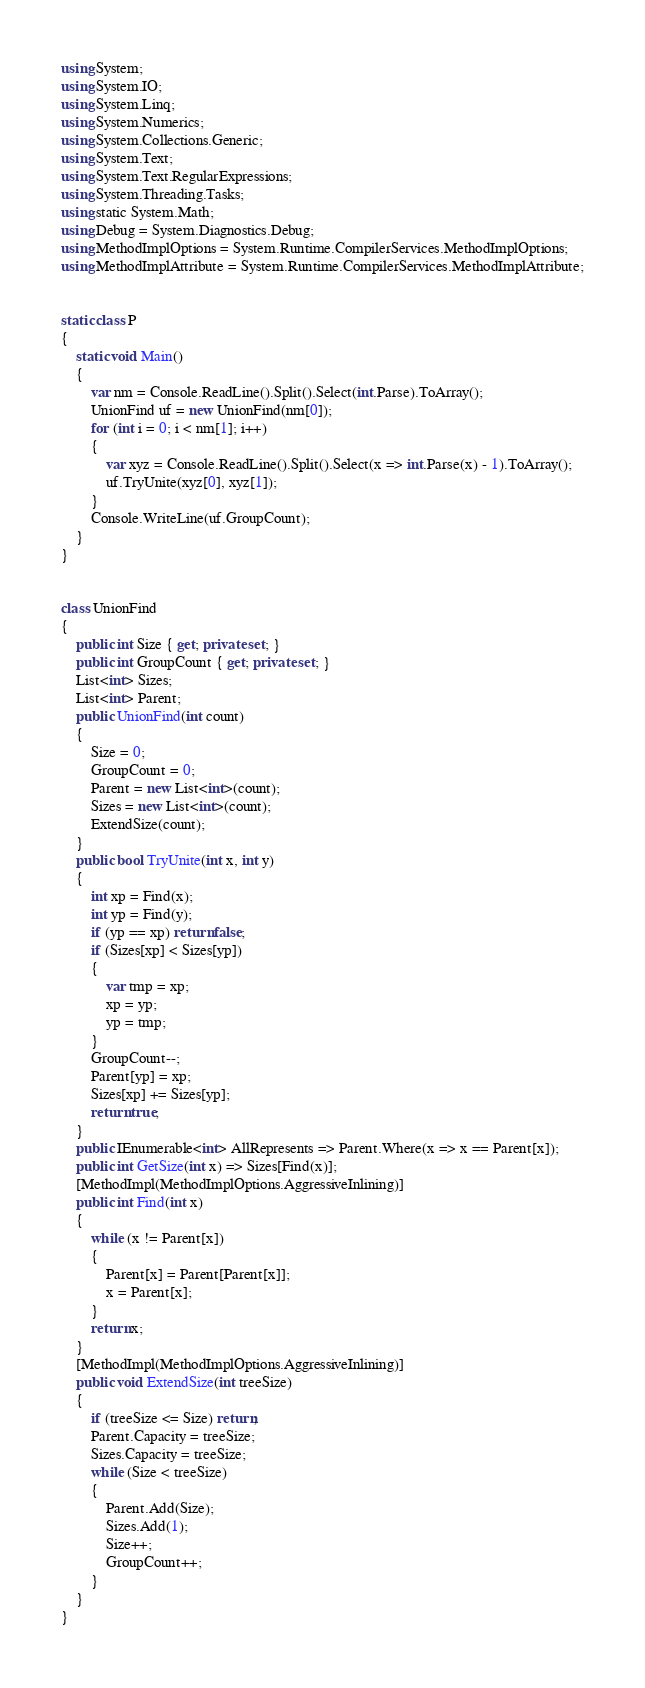Convert code to text. <code><loc_0><loc_0><loc_500><loc_500><_C#_>using System;
using System.IO;
using System.Linq;
using System.Numerics;
using System.Collections.Generic;
using System.Text;
using System.Text.RegularExpressions;
using System.Threading.Tasks;
using static System.Math;
using Debug = System.Diagnostics.Debug;
using MethodImplOptions = System.Runtime.CompilerServices.MethodImplOptions;
using MethodImplAttribute = System.Runtime.CompilerServices.MethodImplAttribute;


static class P
{
    static void Main()
    {
        var nm = Console.ReadLine().Split().Select(int.Parse).ToArray();
        UnionFind uf = new UnionFind(nm[0]);
        for (int i = 0; i < nm[1]; i++)
        {
            var xyz = Console.ReadLine().Split().Select(x => int.Parse(x) - 1).ToArray();
            uf.TryUnite(xyz[0], xyz[1]);
        }
        Console.WriteLine(uf.GroupCount);
    }
}


class UnionFind
{
    public int Size { get; private set; }
    public int GroupCount { get; private set; }
    List<int> Sizes;
    List<int> Parent;
    public UnionFind(int count)
    {
        Size = 0;
        GroupCount = 0;
        Parent = new List<int>(count);
        Sizes = new List<int>(count);
        ExtendSize(count);
    }
    public bool TryUnite(int x, int y)
    {
        int xp = Find(x);
        int yp = Find(y);
        if (yp == xp) return false;
        if (Sizes[xp] < Sizes[yp])
        {
            var tmp = xp;
            xp = yp;
            yp = tmp;
        }
        GroupCount--;
        Parent[yp] = xp;
        Sizes[xp] += Sizes[yp];
        return true;
    }
    public IEnumerable<int> AllRepresents => Parent.Where(x => x == Parent[x]);
    public int GetSize(int x) => Sizes[Find(x)];
    [MethodImpl(MethodImplOptions.AggressiveInlining)]
    public int Find(int x)
    {
        while (x != Parent[x])
        {
            Parent[x] = Parent[Parent[x]];
            x = Parent[x];
        }
        return x;
    }
    [MethodImpl(MethodImplOptions.AggressiveInlining)]
    public void ExtendSize(int treeSize)
    {
        if (treeSize <= Size) return;
        Parent.Capacity = treeSize;
        Sizes.Capacity = treeSize;
        while (Size < treeSize)
        {
            Parent.Add(Size);
            Sizes.Add(1);
            Size++;
            GroupCount++;
        }
    }
}</code> 